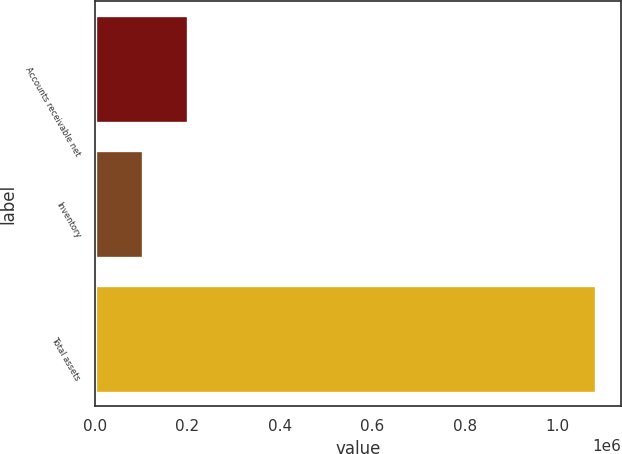<chart> <loc_0><loc_0><loc_500><loc_500><bar_chart><fcel>Accounts receivable net<fcel>Inventory<fcel>Total assets<nl><fcel>202147<fcel>104235<fcel>1.08335e+06<nl></chart> 